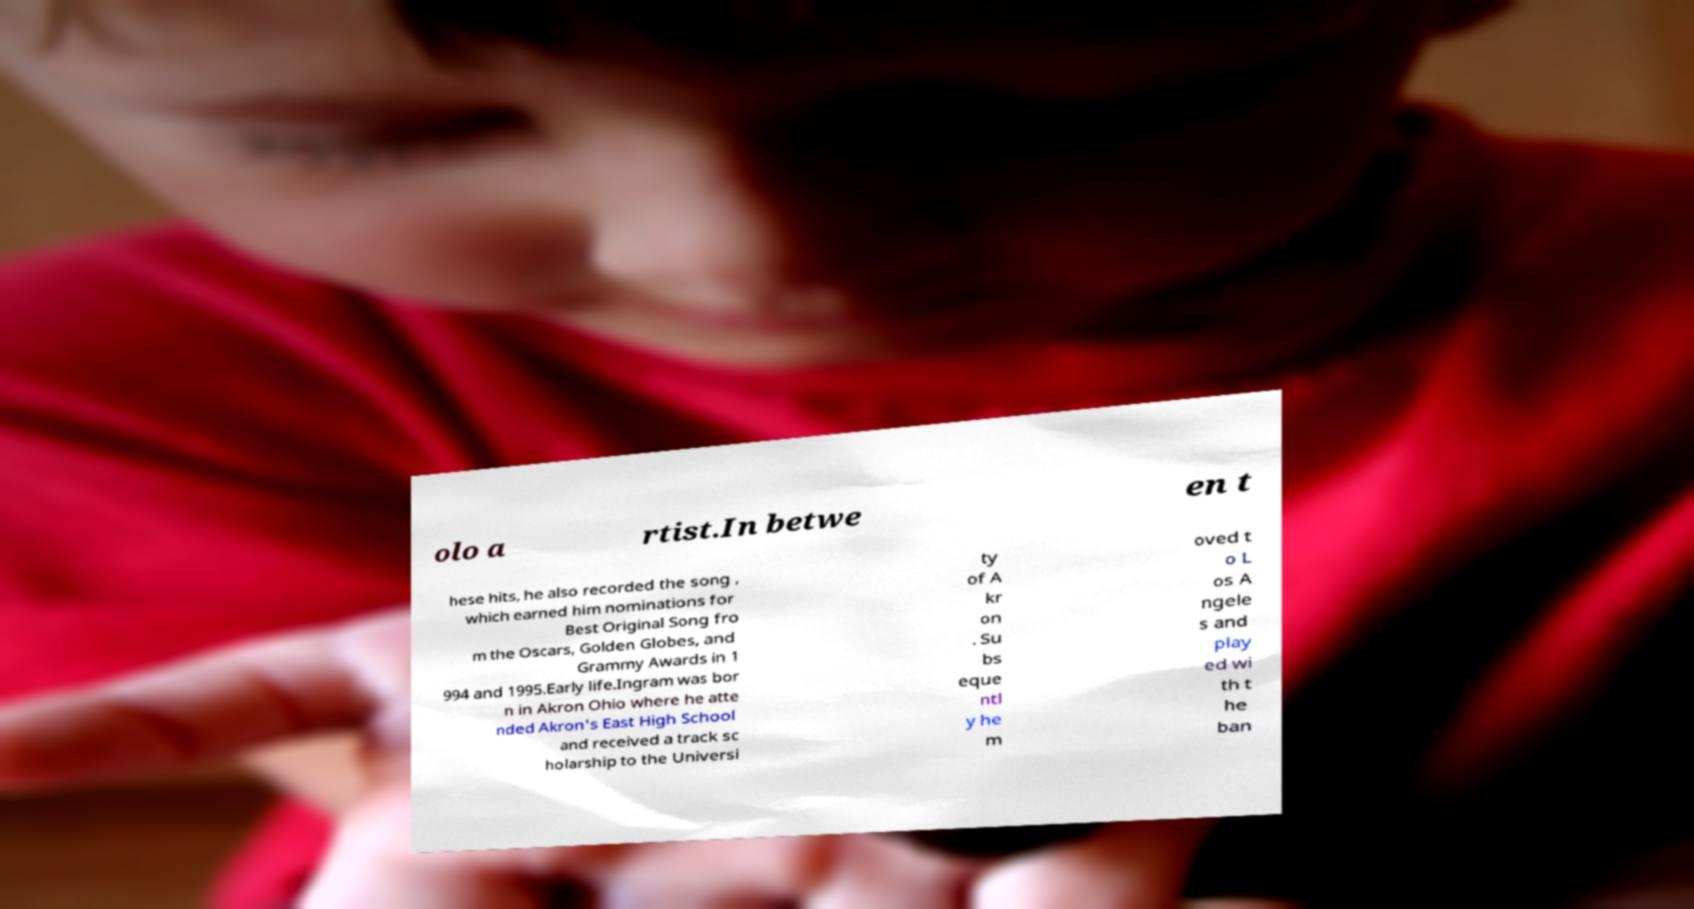Could you assist in decoding the text presented in this image and type it out clearly? olo a rtist.In betwe en t hese hits, he also recorded the song , which earned him nominations for Best Original Song fro m the Oscars, Golden Globes, and Grammy Awards in 1 994 and 1995.Early life.Ingram was bor n in Akron Ohio where he atte nded Akron's East High School and received a track sc holarship to the Universi ty of A kr on . Su bs eque ntl y he m oved t o L os A ngele s and play ed wi th t he ban 